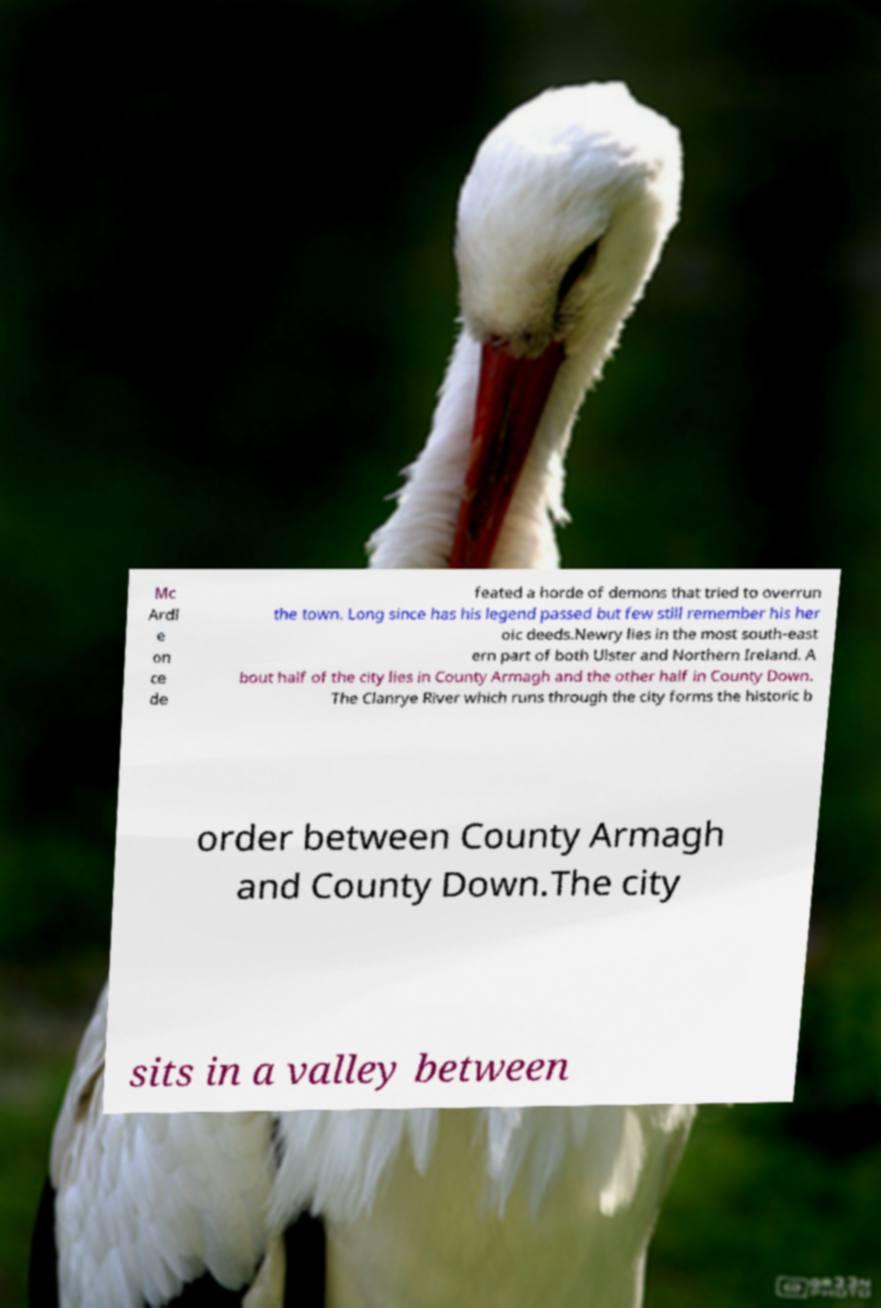Could you assist in decoding the text presented in this image and type it out clearly? Mc Ardl e on ce de feated a horde of demons that tried to overrun the town. Long since has his legend passed but few still remember his her oic deeds.Newry lies in the most south-east ern part of both Ulster and Northern Ireland. A bout half of the city lies in County Armagh and the other half in County Down. The Clanrye River which runs through the city forms the historic b order between County Armagh and County Down.The city sits in a valley between 